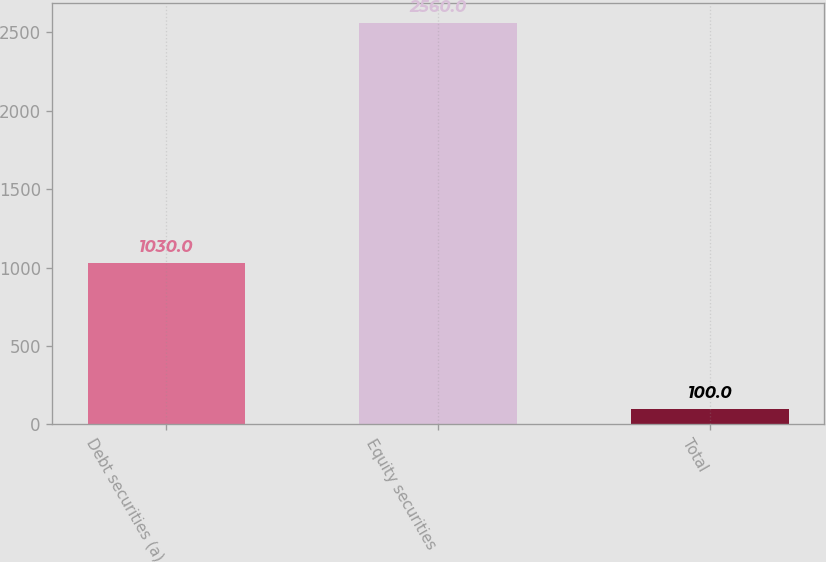<chart> <loc_0><loc_0><loc_500><loc_500><bar_chart><fcel>Debt securities (a)<fcel>Equity securities<fcel>Total<nl><fcel>1030<fcel>2560<fcel>100<nl></chart> 